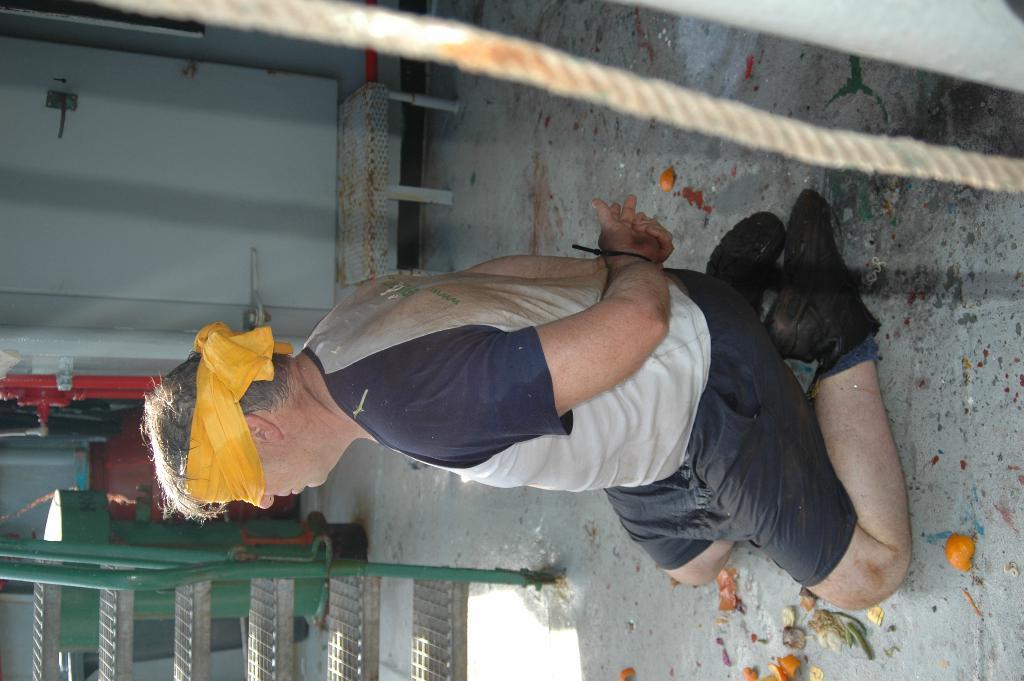Could you give a brief overview of what you see in this image? In this picture there is a woman who is wearing short and shoe. He is a squat position, beside him we can see some vegetables. At the bottom there is a stairs. At the top we can see the rope. On the left there is a door. 